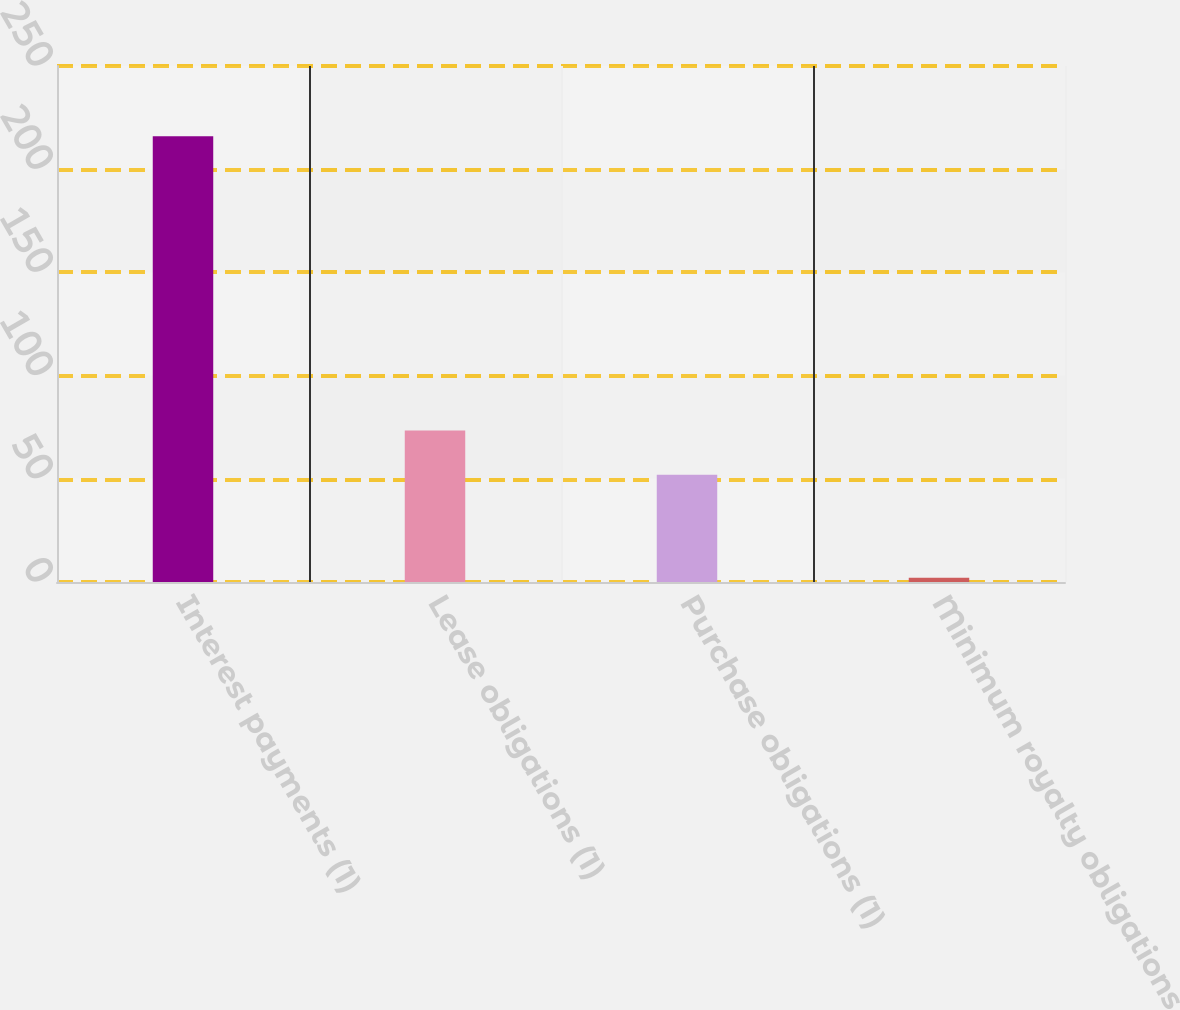<chart> <loc_0><loc_0><loc_500><loc_500><bar_chart><fcel>Interest payments (1)<fcel>Lease obligations (1)<fcel>Purchase obligations (1)<fcel>Minimum royalty obligations<nl><fcel>216<fcel>73.4<fcel>52<fcel>2<nl></chart> 